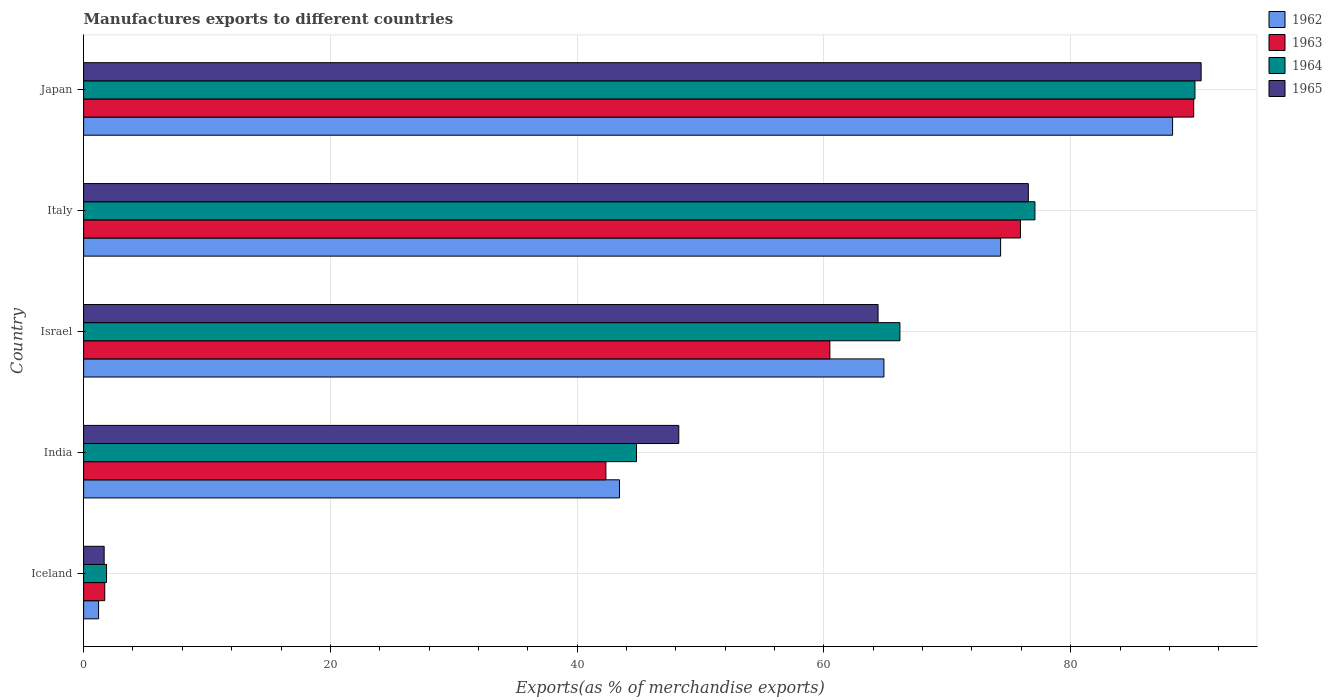How many different coloured bars are there?
Your answer should be very brief. 4. Are the number of bars per tick equal to the number of legend labels?
Offer a very short reply. Yes. Are the number of bars on each tick of the Y-axis equal?
Offer a terse response. Yes. What is the percentage of exports to different countries in 1965 in Italy?
Your answer should be compact. 76.57. Across all countries, what is the maximum percentage of exports to different countries in 1962?
Offer a very short reply. 88.26. Across all countries, what is the minimum percentage of exports to different countries in 1962?
Offer a very short reply. 1.21. In which country was the percentage of exports to different countries in 1964 maximum?
Provide a succinct answer. Japan. What is the total percentage of exports to different countries in 1964 in the graph?
Provide a succinct answer. 280. What is the difference between the percentage of exports to different countries in 1965 in India and that in Israel?
Ensure brevity in your answer.  -16.15. What is the difference between the percentage of exports to different countries in 1964 in Iceland and the percentage of exports to different countries in 1965 in Israel?
Your answer should be compact. -62.53. What is the average percentage of exports to different countries in 1962 per country?
Your answer should be compact. 54.42. What is the difference between the percentage of exports to different countries in 1964 and percentage of exports to different countries in 1962 in Israel?
Provide a succinct answer. 1.3. What is the ratio of the percentage of exports to different countries in 1964 in Iceland to that in Japan?
Keep it short and to the point. 0.02. Is the percentage of exports to different countries in 1962 in Iceland less than that in Japan?
Provide a short and direct response. Yes. What is the difference between the highest and the second highest percentage of exports to different countries in 1963?
Make the answer very short. 14.04. What is the difference between the highest and the lowest percentage of exports to different countries in 1962?
Your response must be concise. 87.05. In how many countries, is the percentage of exports to different countries in 1965 greater than the average percentage of exports to different countries in 1965 taken over all countries?
Offer a terse response. 3. Is the sum of the percentage of exports to different countries in 1965 in India and Italy greater than the maximum percentage of exports to different countries in 1963 across all countries?
Offer a very short reply. Yes. What does the 4th bar from the bottom in India represents?
Your response must be concise. 1965. Is it the case that in every country, the sum of the percentage of exports to different countries in 1963 and percentage of exports to different countries in 1965 is greater than the percentage of exports to different countries in 1962?
Provide a short and direct response. Yes. What is the difference between two consecutive major ticks on the X-axis?
Make the answer very short. 20. Does the graph contain any zero values?
Provide a short and direct response. No. What is the title of the graph?
Your answer should be compact. Manufactures exports to different countries. What is the label or title of the X-axis?
Your answer should be very brief. Exports(as % of merchandise exports). What is the label or title of the Y-axis?
Give a very brief answer. Country. What is the Exports(as % of merchandise exports) in 1962 in Iceland?
Make the answer very short. 1.21. What is the Exports(as % of merchandise exports) of 1963 in Iceland?
Keep it short and to the point. 1.71. What is the Exports(as % of merchandise exports) in 1964 in Iceland?
Provide a short and direct response. 1.86. What is the Exports(as % of merchandise exports) of 1965 in Iceland?
Offer a terse response. 1.66. What is the Exports(as % of merchandise exports) of 1962 in India?
Make the answer very short. 43.43. What is the Exports(as % of merchandise exports) of 1963 in India?
Keep it short and to the point. 42.33. What is the Exports(as % of merchandise exports) of 1964 in India?
Offer a very short reply. 44.81. What is the Exports(as % of merchandise exports) of 1965 in India?
Offer a very short reply. 48.24. What is the Exports(as % of merchandise exports) of 1962 in Israel?
Provide a succinct answer. 64.86. What is the Exports(as % of merchandise exports) of 1963 in Israel?
Keep it short and to the point. 60.48. What is the Exports(as % of merchandise exports) in 1964 in Israel?
Your response must be concise. 66.16. What is the Exports(as % of merchandise exports) in 1965 in Israel?
Provide a succinct answer. 64.39. What is the Exports(as % of merchandise exports) in 1962 in Italy?
Your answer should be very brief. 74.32. What is the Exports(as % of merchandise exports) of 1963 in Italy?
Make the answer very short. 75.93. What is the Exports(as % of merchandise exports) of 1964 in Italy?
Keep it short and to the point. 77.1. What is the Exports(as % of merchandise exports) in 1965 in Italy?
Make the answer very short. 76.57. What is the Exports(as % of merchandise exports) in 1962 in Japan?
Your answer should be very brief. 88.26. What is the Exports(as % of merchandise exports) in 1963 in Japan?
Your answer should be very brief. 89.97. What is the Exports(as % of merchandise exports) of 1964 in Japan?
Your response must be concise. 90.07. What is the Exports(as % of merchandise exports) of 1965 in Japan?
Ensure brevity in your answer.  90.57. Across all countries, what is the maximum Exports(as % of merchandise exports) in 1962?
Give a very brief answer. 88.26. Across all countries, what is the maximum Exports(as % of merchandise exports) of 1963?
Offer a terse response. 89.97. Across all countries, what is the maximum Exports(as % of merchandise exports) in 1964?
Your response must be concise. 90.07. Across all countries, what is the maximum Exports(as % of merchandise exports) of 1965?
Provide a succinct answer. 90.57. Across all countries, what is the minimum Exports(as % of merchandise exports) of 1962?
Your answer should be compact. 1.21. Across all countries, what is the minimum Exports(as % of merchandise exports) in 1963?
Your answer should be compact. 1.71. Across all countries, what is the minimum Exports(as % of merchandise exports) in 1964?
Keep it short and to the point. 1.86. Across all countries, what is the minimum Exports(as % of merchandise exports) in 1965?
Make the answer very short. 1.66. What is the total Exports(as % of merchandise exports) in 1962 in the graph?
Provide a short and direct response. 272.09. What is the total Exports(as % of merchandise exports) of 1963 in the graph?
Keep it short and to the point. 270.42. What is the total Exports(as % of merchandise exports) in 1964 in the graph?
Provide a succinct answer. 280. What is the total Exports(as % of merchandise exports) of 1965 in the graph?
Your answer should be very brief. 281.43. What is the difference between the Exports(as % of merchandise exports) in 1962 in Iceland and that in India?
Offer a terse response. -42.22. What is the difference between the Exports(as % of merchandise exports) of 1963 in Iceland and that in India?
Your answer should be compact. -40.62. What is the difference between the Exports(as % of merchandise exports) in 1964 in Iceland and that in India?
Give a very brief answer. -42.95. What is the difference between the Exports(as % of merchandise exports) of 1965 in Iceland and that in India?
Provide a short and direct response. -46.57. What is the difference between the Exports(as % of merchandise exports) in 1962 in Iceland and that in Israel?
Provide a succinct answer. -63.65. What is the difference between the Exports(as % of merchandise exports) of 1963 in Iceland and that in Israel?
Offer a terse response. -58.77. What is the difference between the Exports(as % of merchandise exports) in 1964 in Iceland and that in Israel?
Make the answer very short. -64.3. What is the difference between the Exports(as % of merchandise exports) in 1965 in Iceland and that in Israel?
Give a very brief answer. -62.73. What is the difference between the Exports(as % of merchandise exports) in 1962 in Iceland and that in Italy?
Make the answer very short. -73.11. What is the difference between the Exports(as % of merchandise exports) of 1963 in Iceland and that in Italy?
Provide a short and direct response. -74.22. What is the difference between the Exports(as % of merchandise exports) of 1964 in Iceland and that in Italy?
Provide a succinct answer. -75.25. What is the difference between the Exports(as % of merchandise exports) in 1965 in Iceland and that in Italy?
Provide a succinct answer. -74.9. What is the difference between the Exports(as % of merchandise exports) in 1962 in Iceland and that in Japan?
Provide a succinct answer. -87.05. What is the difference between the Exports(as % of merchandise exports) of 1963 in Iceland and that in Japan?
Provide a succinct answer. -88.26. What is the difference between the Exports(as % of merchandise exports) of 1964 in Iceland and that in Japan?
Ensure brevity in your answer.  -88.22. What is the difference between the Exports(as % of merchandise exports) of 1965 in Iceland and that in Japan?
Your answer should be very brief. -88.91. What is the difference between the Exports(as % of merchandise exports) in 1962 in India and that in Israel?
Provide a short and direct response. -21.43. What is the difference between the Exports(as % of merchandise exports) of 1963 in India and that in Israel?
Your response must be concise. -18.15. What is the difference between the Exports(as % of merchandise exports) of 1964 in India and that in Israel?
Keep it short and to the point. -21.35. What is the difference between the Exports(as % of merchandise exports) in 1965 in India and that in Israel?
Offer a terse response. -16.15. What is the difference between the Exports(as % of merchandise exports) in 1962 in India and that in Italy?
Ensure brevity in your answer.  -30.89. What is the difference between the Exports(as % of merchandise exports) in 1963 in India and that in Italy?
Provide a succinct answer. -33.6. What is the difference between the Exports(as % of merchandise exports) in 1964 in India and that in Italy?
Ensure brevity in your answer.  -32.3. What is the difference between the Exports(as % of merchandise exports) of 1965 in India and that in Italy?
Offer a terse response. -28.33. What is the difference between the Exports(as % of merchandise exports) of 1962 in India and that in Japan?
Offer a very short reply. -44.83. What is the difference between the Exports(as % of merchandise exports) of 1963 in India and that in Japan?
Provide a short and direct response. -47.64. What is the difference between the Exports(as % of merchandise exports) of 1964 in India and that in Japan?
Your answer should be compact. -45.26. What is the difference between the Exports(as % of merchandise exports) in 1965 in India and that in Japan?
Provide a short and direct response. -42.34. What is the difference between the Exports(as % of merchandise exports) of 1962 in Israel and that in Italy?
Provide a short and direct response. -9.46. What is the difference between the Exports(as % of merchandise exports) of 1963 in Israel and that in Italy?
Give a very brief answer. -15.45. What is the difference between the Exports(as % of merchandise exports) of 1964 in Israel and that in Italy?
Provide a succinct answer. -10.94. What is the difference between the Exports(as % of merchandise exports) of 1965 in Israel and that in Italy?
Ensure brevity in your answer.  -12.18. What is the difference between the Exports(as % of merchandise exports) in 1962 in Israel and that in Japan?
Offer a terse response. -23.4. What is the difference between the Exports(as % of merchandise exports) in 1963 in Israel and that in Japan?
Your answer should be very brief. -29.49. What is the difference between the Exports(as % of merchandise exports) in 1964 in Israel and that in Japan?
Give a very brief answer. -23.91. What is the difference between the Exports(as % of merchandise exports) in 1965 in Israel and that in Japan?
Your answer should be compact. -26.18. What is the difference between the Exports(as % of merchandise exports) in 1962 in Italy and that in Japan?
Ensure brevity in your answer.  -13.94. What is the difference between the Exports(as % of merchandise exports) of 1963 in Italy and that in Japan?
Your response must be concise. -14.04. What is the difference between the Exports(as % of merchandise exports) in 1964 in Italy and that in Japan?
Provide a short and direct response. -12.97. What is the difference between the Exports(as % of merchandise exports) in 1965 in Italy and that in Japan?
Give a very brief answer. -14.01. What is the difference between the Exports(as % of merchandise exports) in 1962 in Iceland and the Exports(as % of merchandise exports) in 1963 in India?
Ensure brevity in your answer.  -41.12. What is the difference between the Exports(as % of merchandise exports) in 1962 in Iceland and the Exports(as % of merchandise exports) in 1964 in India?
Offer a very short reply. -43.6. What is the difference between the Exports(as % of merchandise exports) in 1962 in Iceland and the Exports(as % of merchandise exports) in 1965 in India?
Provide a short and direct response. -47.03. What is the difference between the Exports(as % of merchandise exports) of 1963 in Iceland and the Exports(as % of merchandise exports) of 1964 in India?
Offer a terse response. -43.1. What is the difference between the Exports(as % of merchandise exports) in 1963 in Iceland and the Exports(as % of merchandise exports) in 1965 in India?
Ensure brevity in your answer.  -46.53. What is the difference between the Exports(as % of merchandise exports) in 1964 in Iceland and the Exports(as % of merchandise exports) in 1965 in India?
Keep it short and to the point. -46.38. What is the difference between the Exports(as % of merchandise exports) of 1962 in Iceland and the Exports(as % of merchandise exports) of 1963 in Israel?
Offer a very short reply. -59.27. What is the difference between the Exports(as % of merchandise exports) in 1962 in Iceland and the Exports(as % of merchandise exports) in 1964 in Israel?
Your response must be concise. -64.95. What is the difference between the Exports(as % of merchandise exports) in 1962 in Iceland and the Exports(as % of merchandise exports) in 1965 in Israel?
Offer a very short reply. -63.18. What is the difference between the Exports(as % of merchandise exports) of 1963 in Iceland and the Exports(as % of merchandise exports) of 1964 in Israel?
Keep it short and to the point. -64.45. What is the difference between the Exports(as % of merchandise exports) in 1963 in Iceland and the Exports(as % of merchandise exports) in 1965 in Israel?
Your answer should be compact. -62.68. What is the difference between the Exports(as % of merchandise exports) in 1964 in Iceland and the Exports(as % of merchandise exports) in 1965 in Israel?
Keep it short and to the point. -62.53. What is the difference between the Exports(as % of merchandise exports) in 1962 in Iceland and the Exports(as % of merchandise exports) in 1963 in Italy?
Make the answer very short. -74.72. What is the difference between the Exports(as % of merchandise exports) of 1962 in Iceland and the Exports(as % of merchandise exports) of 1964 in Italy?
Keep it short and to the point. -75.89. What is the difference between the Exports(as % of merchandise exports) of 1962 in Iceland and the Exports(as % of merchandise exports) of 1965 in Italy?
Offer a terse response. -75.36. What is the difference between the Exports(as % of merchandise exports) of 1963 in Iceland and the Exports(as % of merchandise exports) of 1964 in Italy?
Offer a very short reply. -75.39. What is the difference between the Exports(as % of merchandise exports) of 1963 in Iceland and the Exports(as % of merchandise exports) of 1965 in Italy?
Offer a very short reply. -74.86. What is the difference between the Exports(as % of merchandise exports) in 1964 in Iceland and the Exports(as % of merchandise exports) in 1965 in Italy?
Keep it short and to the point. -74.71. What is the difference between the Exports(as % of merchandise exports) of 1962 in Iceland and the Exports(as % of merchandise exports) of 1963 in Japan?
Provide a short and direct response. -88.76. What is the difference between the Exports(as % of merchandise exports) in 1962 in Iceland and the Exports(as % of merchandise exports) in 1964 in Japan?
Keep it short and to the point. -88.86. What is the difference between the Exports(as % of merchandise exports) of 1962 in Iceland and the Exports(as % of merchandise exports) of 1965 in Japan?
Provide a short and direct response. -89.36. What is the difference between the Exports(as % of merchandise exports) in 1963 in Iceland and the Exports(as % of merchandise exports) in 1964 in Japan?
Provide a short and direct response. -88.36. What is the difference between the Exports(as % of merchandise exports) in 1963 in Iceland and the Exports(as % of merchandise exports) in 1965 in Japan?
Offer a terse response. -88.86. What is the difference between the Exports(as % of merchandise exports) in 1964 in Iceland and the Exports(as % of merchandise exports) in 1965 in Japan?
Offer a terse response. -88.72. What is the difference between the Exports(as % of merchandise exports) in 1962 in India and the Exports(as % of merchandise exports) in 1963 in Israel?
Your response must be concise. -17.05. What is the difference between the Exports(as % of merchandise exports) in 1962 in India and the Exports(as % of merchandise exports) in 1964 in Israel?
Offer a very short reply. -22.73. What is the difference between the Exports(as % of merchandise exports) in 1962 in India and the Exports(as % of merchandise exports) in 1965 in Israel?
Provide a short and direct response. -20.96. What is the difference between the Exports(as % of merchandise exports) of 1963 in India and the Exports(as % of merchandise exports) of 1964 in Israel?
Your response must be concise. -23.83. What is the difference between the Exports(as % of merchandise exports) of 1963 in India and the Exports(as % of merchandise exports) of 1965 in Israel?
Your response must be concise. -22.06. What is the difference between the Exports(as % of merchandise exports) in 1964 in India and the Exports(as % of merchandise exports) in 1965 in Israel?
Offer a very short reply. -19.58. What is the difference between the Exports(as % of merchandise exports) of 1962 in India and the Exports(as % of merchandise exports) of 1963 in Italy?
Make the answer very short. -32.49. What is the difference between the Exports(as % of merchandise exports) in 1962 in India and the Exports(as % of merchandise exports) in 1964 in Italy?
Provide a succinct answer. -33.67. What is the difference between the Exports(as % of merchandise exports) in 1962 in India and the Exports(as % of merchandise exports) in 1965 in Italy?
Provide a short and direct response. -33.13. What is the difference between the Exports(as % of merchandise exports) of 1963 in India and the Exports(as % of merchandise exports) of 1964 in Italy?
Make the answer very short. -34.77. What is the difference between the Exports(as % of merchandise exports) in 1963 in India and the Exports(as % of merchandise exports) in 1965 in Italy?
Offer a terse response. -34.24. What is the difference between the Exports(as % of merchandise exports) of 1964 in India and the Exports(as % of merchandise exports) of 1965 in Italy?
Provide a succinct answer. -31.76. What is the difference between the Exports(as % of merchandise exports) of 1962 in India and the Exports(as % of merchandise exports) of 1963 in Japan?
Keep it short and to the point. -46.54. What is the difference between the Exports(as % of merchandise exports) of 1962 in India and the Exports(as % of merchandise exports) of 1964 in Japan?
Offer a terse response. -46.64. What is the difference between the Exports(as % of merchandise exports) of 1962 in India and the Exports(as % of merchandise exports) of 1965 in Japan?
Keep it short and to the point. -47.14. What is the difference between the Exports(as % of merchandise exports) in 1963 in India and the Exports(as % of merchandise exports) in 1964 in Japan?
Make the answer very short. -47.74. What is the difference between the Exports(as % of merchandise exports) of 1963 in India and the Exports(as % of merchandise exports) of 1965 in Japan?
Make the answer very short. -48.24. What is the difference between the Exports(as % of merchandise exports) in 1964 in India and the Exports(as % of merchandise exports) in 1965 in Japan?
Your response must be concise. -45.76. What is the difference between the Exports(as % of merchandise exports) in 1962 in Israel and the Exports(as % of merchandise exports) in 1963 in Italy?
Offer a very short reply. -11.07. What is the difference between the Exports(as % of merchandise exports) in 1962 in Israel and the Exports(as % of merchandise exports) in 1964 in Italy?
Provide a short and direct response. -12.24. What is the difference between the Exports(as % of merchandise exports) of 1962 in Israel and the Exports(as % of merchandise exports) of 1965 in Italy?
Ensure brevity in your answer.  -11.7. What is the difference between the Exports(as % of merchandise exports) in 1963 in Israel and the Exports(as % of merchandise exports) in 1964 in Italy?
Your answer should be very brief. -16.62. What is the difference between the Exports(as % of merchandise exports) of 1963 in Israel and the Exports(as % of merchandise exports) of 1965 in Italy?
Offer a terse response. -16.08. What is the difference between the Exports(as % of merchandise exports) of 1964 in Israel and the Exports(as % of merchandise exports) of 1965 in Italy?
Make the answer very short. -10.41. What is the difference between the Exports(as % of merchandise exports) in 1962 in Israel and the Exports(as % of merchandise exports) in 1963 in Japan?
Provide a succinct answer. -25.11. What is the difference between the Exports(as % of merchandise exports) of 1962 in Israel and the Exports(as % of merchandise exports) of 1964 in Japan?
Offer a very short reply. -25.21. What is the difference between the Exports(as % of merchandise exports) of 1962 in Israel and the Exports(as % of merchandise exports) of 1965 in Japan?
Offer a very short reply. -25.71. What is the difference between the Exports(as % of merchandise exports) in 1963 in Israel and the Exports(as % of merchandise exports) in 1964 in Japan?
Provide a short and direct response. -29.59. What is the difference between the Exports(as % of merchandise exports) of 1963 in Israel and the Exports(as % of merchandise exports) of 1965 in Japan?
Keep it short and to the point. -30.09. What is the difference between the Exports(as % of merchandise exports) in 1964 in Israel and the Exports(as % of merchandise exports) in 1965 in Japan?
Provide a short and direct response. -24.41. What is the difference between the Exports(as % of merchandise exports) of 1962 in Italy and the Exports(as % of merchandise exports) of 1963 in Japan?
Your answer should be very brief. -15.65. What is the difference between the Exports(as % of merchandise exports) of 1962 in Italy and the Exports(as % of merchandise exports) of 1964 in Japan?
Offer a very short reply. -15.75. What is the difference between the Exports(as % of merchandise exports) of 1962 in Italy and the Exports(as % of merchandise exports) of 1965 in Japan?
Offer a terse response. -16.25. What is the difference between the Exports(as % of merchandise exports) of 1963 in Italy and the Exports(as % of merchandise exports) of 1964 in Japan?
Your answer should be very brief. -14.14. What is the difference between the Exports(as % of merchandise exports) in 1963 in Italy and the Exports(as % of merchandise exports) in 1965 in Japan?
Keep it short and to the point. -14.64. What is the difference between the Exports(as % of merchandise exports) of 1964 in Italy and the Exports(as % of merchandise exports) of 1965 in Japan?
Your answer should be very brief. -13.47. What is the average Exports(as % of merchandise exports) in 1962 per country?
Offer a very short reply. 54.42. What is the average Exports(as % of merchandise exports) in 1963 per country?
Your answer should be very brief. 54.08. What is the average Exports(as % of merchandise exports) in 1964 per country?
Provide a succinct answer. 56. What is the average Exports(as % of merchandise exports) in 1965 per country?
Offer a very short reply. 56.29. What is the difference between the Exports(as % of merchandise exports) in 1962 and Exports(as % of merchandise exports) in 1964 in Iceland?
Offer a very short reply. -0.65. What is the difference between the Exports(as % of merchandise exports) of 1962 and Exports(as % of merchandise exports) of 1965 in Iceland?
Offer a very short reply. -0.45. What is the difference between the Exports(as % of merchandise exports) of 1963 and Exports(as % of merchandise exports) of 1964 in Iceland?
Offer a terse response. -0.15. What is the difference between the Exports(as % of merchandise exports) of 1963 and Exports(as % of merchandise exports) of 1965 in Iceland?
Provide a short and direct response. 0.05. What is the difference between the Exports(as % of merchandise exports) in 1964 and Exports(as % of merchandise exports) in 1965 in Iceland?
Give a very brief answer. 0.19. What is the difference between the Exports(as % of merchandise exports) of 1962 and Exports(as % of merchandise exports) of 1963 in India?
Make the answer very short. 1.11. What is the difference between the Exports(as % of merchandise exports) in 1962 and Exports(as % of merchandise exports) in 1964 in India?
Ensure brevity in your answer.  -1.37. What is the difference between the Exports(as % of merchandise exports) in 1962 and Exports(as % of merchandise exports) in 1965 in India?
Provide a short and direct response. -4.8. What is the difference between the Exports(as % of merchandise exports) of 1963 and Exports(as % of merchandise exports) of 1964 in India?
Your answer should be compact. -2.48. What is the difference between the Exports(as % of merchandise exports) in 1963 and Exports(as % of merchandise exports) in 1965 in India?
Offer a terse response. -5.91. What is the difference between the Exports(as % of merchandise exports) in 1964 and Exports(as % of merchandise exports) in 1965 in India?
Your answer should be very brief. -3.43. What is the difference between the Exports(as % of merchandise exports) in 1962 and Exports(as % of merchandise exports) in 1963 in Israel?
Your answer should be compact. 4.38. What is the difference between the Exports(as % of merchandise exports) in 1962 and Exports(as % of merchandise exports) in 1964 in Israel?
Ensure brevity in your answer.  -1.3. What is the difference between the Exports(as % of merchandise exports) of 1962 and Exports(as % of merchandise exports) of 1965 in Israel?
Give a very brief answer. 0.47. What is the difference between the Exports(as % of merchandise exports) of 1963 and Exports(as % of merchandise exports) of 1964 in Israel?
Provide a short and direct response. -5.68. What is the difference between the Exports(as % of merchandise exports) in 1963 and Exports(as % of merchandise exports) in 1965 in Israel?
Your response must be concise. -3.91. What is the difference between the Exports(as % of merchandise exports) of 1964 and Exports(as % of merchandise exports) of 1965 in Israel?
Ensure brevity in your answer.  1.77. What is the difference between the Exports(as % of merchandise exports) of 1962 and Exports(as % of merchandise exports) of 1963 in Italy?
Your answer should be compact. -1.61. What is the difference between the Exports(as % of merchandise exports) in 1962 and Exports(as % of merchandise exports) in 1964 in Italy?
Your response must be concise. -2.78. What is the difference between the Exports(as % of merchandise exports) in 1962 and Exports(as % of merchandise exports) in 1965 in Italy?
Provide a short and direct response. -2.25. What is the difference between the Exports(as % of merchandise exports) in 1963 and Exports(as % of merchandise exports) in 1964 in Italy?
Your response must be concise. -1.17. What is the difference between the Exports(as % of merchandise exports) in 1963 and Exports(as % of merchandise exports) in 1965 in Italy?
Make the answer very short. -0.64. What is the difference between the Exports(as % of merchandise exports) of 1964 and Exports(as % of merchandise exports) of 1965 in Italy?
Offer a terse response. 0.54. What is the difference between the Exports(as % of merchandise exports) in 1962 and Exports(as % of merchandise exports) in 1963 in Japan?
Your answer should be compact. -1.71. What is the difference between the Exports(as % of merchandise exports) in 1962 and Exports(as % of merchandise exports) in 1964 in Japan?
Offer a terse response. -1.81. What is the difference between the Exports(as % of merchandise exports) of 1962 and Exports(as % of merchandise exports) of 1965 in Japan?
Offer a terse response. -2.31. What is the difference between the Exports(as % of merchandise exports) of 1963 and Exports(as % of merchandise exports) of 1964 in Japan?
Your answer should be compact. -0.1. What is the difference between the Exports(as % of merchandise exports) of 1963 and Exports(as % of merchandise exports) of 1965 in Japan?
Your answer should be compact. -0.6. What is the difference between the Exports(as % of merchandise exports) in 1964 and Exports(as % of merchandise exports) in 1965 in Japan?
Your answer should be very brief. -0.5. What is the ratio of the Exports(as % of merchandise exports) of 1962 in Iceland to that in India?
Your answer should be very brief. 0.03. What is the ratio of the Exports(as % of merchandise exports) in 1963 in Iceland to that in India?
Your answer should be very brief. 0.04. What is the ratio of the Exports(as % of merchandise exports) of 1964 in Iceland to that in India?
Keep it short and to the point. 0.04. What is the ratio of the Exports(as % of merchandise exports) of 1965 in Iceland to that in India?
Your response must be concise. 0.03. What is the ratio of the Exports(as % of merchandise exports) of 1962 in Iceland to that in Israel?
Ensure brevity in your answer.  0.02. What is the ratio of the Exports(as % of merchandise exports) in 1963 in Iceland to that in Israel?
Provide a short and direct response. 0.03. What is the ratio of the Exports(as % of merchandise exports) of 1964 in Iceland to that in Israel?
Keep it short and to the point. 0.03. What is the ratio of the Exports(as % of merchandise exports) of 1965 in Iceland to that in Israel?
Your answer should be compact. 0.03. What is the ratio of the Exports(as % of merchandise exports) in 1962 in Iceland to that in Italy?
Provide a succinct answer. 0.02. What is the ratio of the Exports(as % of merchandise exports) of 1963 in Iceland to that in Italy?
Provide a succinct answer. 0.02. What is the ratio of the Exports(as % of merchandise exports) of 1964 in Iceland to that in Italy?
Offer a terse response. 0.02. What is the ratio of the Exports(as % of merchandise exports) in 1965 in Iceland to that in Italy?
Offer a very short reply. 0.02. What is the ratio of the Exports(as % of merchandise exports) of 1962 in Iceland to that in Japan?
Give a very brief answer. 0.01. What is the ratio of the Exports(as % of merchandise exports) in 1963 in Iceland to that in Japan?
Provide a short and direct response. 0.02. What is the ratio of the Exports(as % of merchandise exports) in 1964 in Iceland to that in Japan?
Offer a terse response. 0.02. What is the ratio of the Exports(as % of merchandise exports) in 1965 in Iceland to that in Japan?
Ensure brevity in your answer.  0.02. What is the ratio of the Exports(as % of merchandise exports) of 1962 in India to that in Israel?
Offer a terse response. 0.67. What is the ratio of the Exports(as % of merchandise exports) of 1963 in India to that in Israel?
Your answer should be compact. 0.7. What is the ratio of the Exports(as % of merchandise exports) of 1964 in India to that in Israel?
Keep it short and to the point. 0.68. What is the ratio of the Exports(as % of merchandise exports) of 1965 in India to that in Israel?
Keep it short and to the point. 0.75. What is the ratio of the Exports(as % of merchandise exports) in 1962 in India to that in Italy?
Make the answer very short. 0.58. What is the ratio of the Exports(as % of merchandise exports) of 1963 in India to that in Italy?
Offer a very short reply. 0.56. What is the ratio of the Exports(as % of merchandise exports) in 1964 in India to that in Italy?
Your answer should be compact. 0.58. What is the ratio of the Exports(as % of merchandise exports) in 1965 in India to that in Italy?
Your answer should be compact. 0.63. What is the ratio of the Exports(as % of merchandise exports) of 1962 in India to that in Japan?
Offer a very short reply. 0.49. What is the ratio of the Exports(as % of merchandise exports) of 1963 in India to that in Japan?
Offer a very short reply. 0.47. What is the ratio of the Exports(as % of merchandise exports) in 1964 in India to that in Japan?
Ensure brevity in your answer.  0.5. What is the ratio of the Exports(as % of merchandise exports) of 1965 in India to that in Japan?
Offer a terse response. 0.53. What is the ratio of the Exports(as % of merchandise exports) of 1962 in Israel to that in Italy?
Offer a terse response. 0.87. What is the ratio of the Exports(as % of merchandise exports) in 1963 in Israel to that in Italy?
Your response must be concise. 0.8. What is the ratio of the Exports(as % of merchandise exports) of 1964 in Israel to that in Italy?
Your answer should be compact. 0.86. What is the ratio of the Exports(as % of merchandise exports) of 1965 in Israel to that in Italy?
Give a very brief answer. 0.84. What is the ratio of the Exports(as % of merchandise exports) in 1962 in Israel to that in Japan?
Provide a succinct answer. 0.73. What is the ratio of the Exports(as % of merchandise exports) in 1963 in Israel to that in Japan?
Offer a terse response. 0.67. What is the ratio of the Exports(as % of merchandise exports) of 1964 in Israel to that in Japan?
Offer a terse response. 0.73. What is the ratio of the Exports(as % of merchandise exports) in 1965 in Israel to that in Japan?
Offer a very short reply. 0.71. What is the ratio of the Exports(as % of merchandise exports) in 1962 in Italy to that in Japan?
Keep it short and to the point. 0.84. What is the ratio of the Exports(as % of merchandise exports) in 1963 in Italy to that in Japan?
Offer a terse response. 0.84. What is the ratio of the Exports(as % of merchandise exports) of 1964 in Italy to that in Japan?
Ensure brevity in your answer.  0.86. What is the ratio of the Exports(as % of merchandise exports) of 1965 in Italy to that in Japan?
Provide a short and direct response. 0.85. What is the difference between the highest and the second highest Exports(as % of merchandise exports) of 1962?
Make the answer very short. 13.94. What is the difference between the highest and the second highest Exports(as % of merchandise exports) of 1963?
Give a very brief answer. 14.04. What is the difference between the highest and the second highest Exports(as % of merchandise exports) in 1964?
Give a very brief answer. 12.97. What is the difference between the highest and the second highest Exports(as % of merchandise exports) in 1965?
Make the answer very short. 14.01. What is the difference between the highest and the lowest Exports(as % of merchandise exports) of 1962?
Offer a very short reply. 87.05. What is the difference between the highest and the lowest Exports(as % of merchandise exports) of 1963?
Offer a very short reply. 88.26. What is the difference between the highest and the lowest Exports(as % of merchandise exports) in 1964?
Offer a very short reply. 88.22. What is the difference between the highest and the lowest Exports(as % of merchandise exports) in 1965?
Your response must be concise. 88.91. 